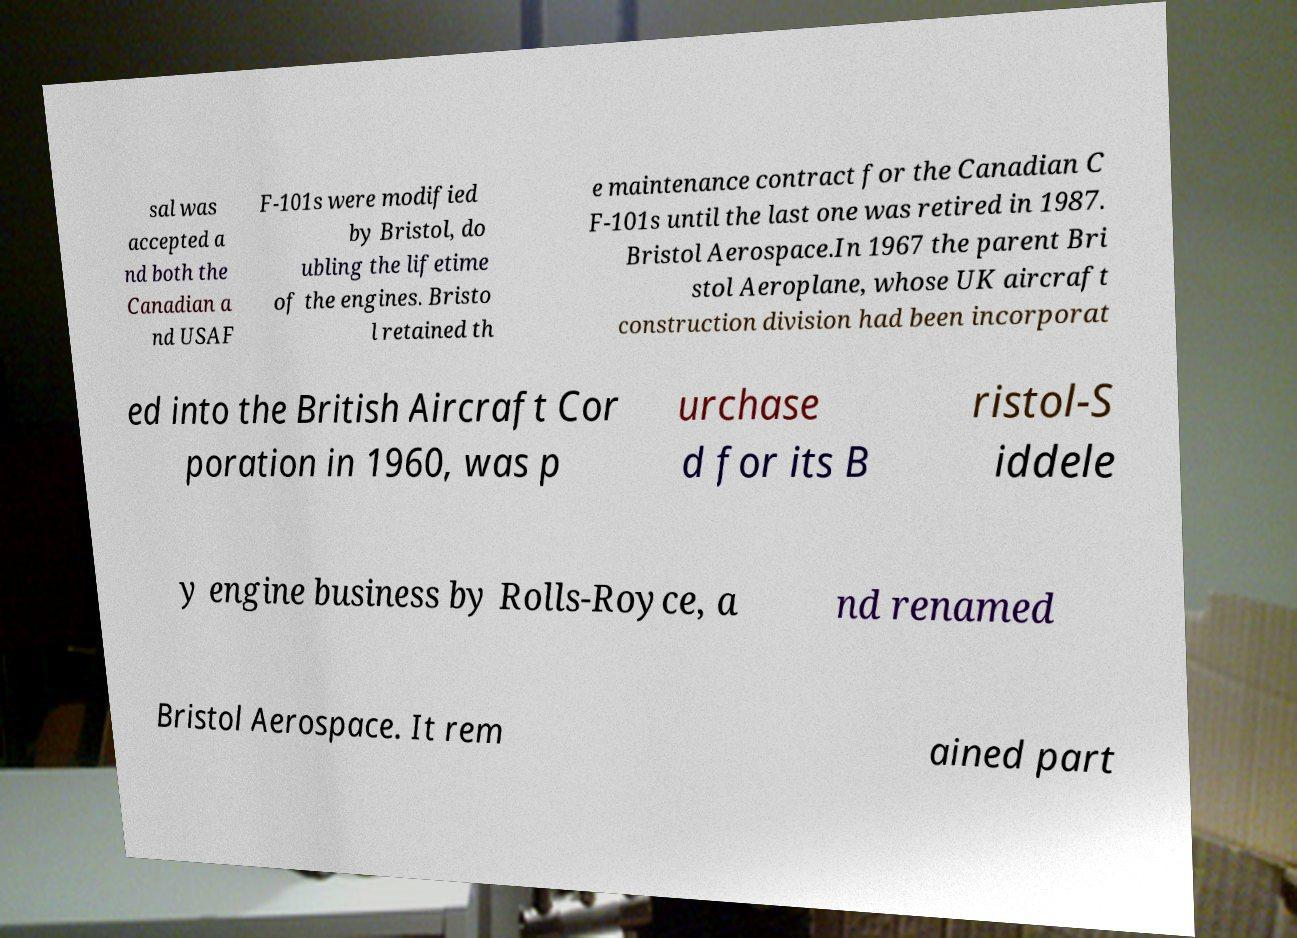Could you assist in decoding the text presented in this image and type it out clearly? sal was accepted a nd both the Canadian a nd USAF F-101s were modified by Bristol, do ubling the lifetime of the engines. Bristo l retained th e maintenance contract for the Canadian C F-101s until the last one was retired in 1987. Bristol Aerospace.In 1967 the parent Bri stol Aeroplane, whose UK aircraft construction division had been incorporat ed into the British Aircraft Cor poration in 1960, was p urchase d for its B ristol-S iddele y engine business by Rolls-Royce, a nd renamed Bristol Aerospace. It rem ained part 